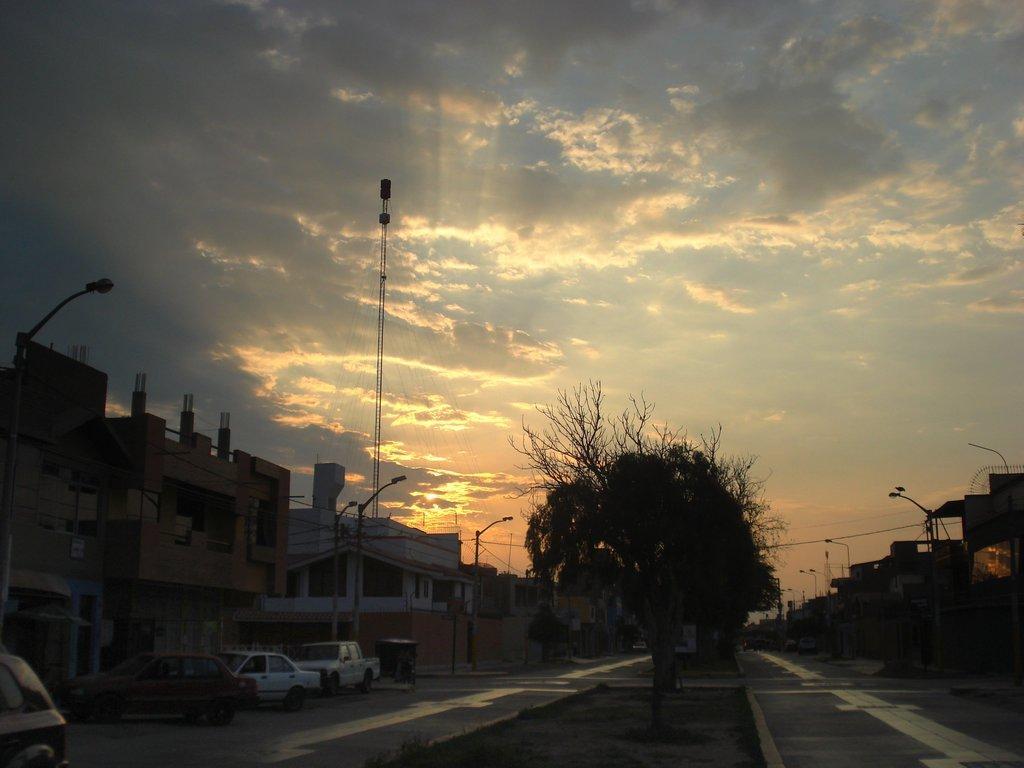How would you summarize this image in a sentence or two? In this image we can see few buildings, there are few vehicles on the road near the buildings, there are street lights, trees, a rod and the sky with clouds in the background. 